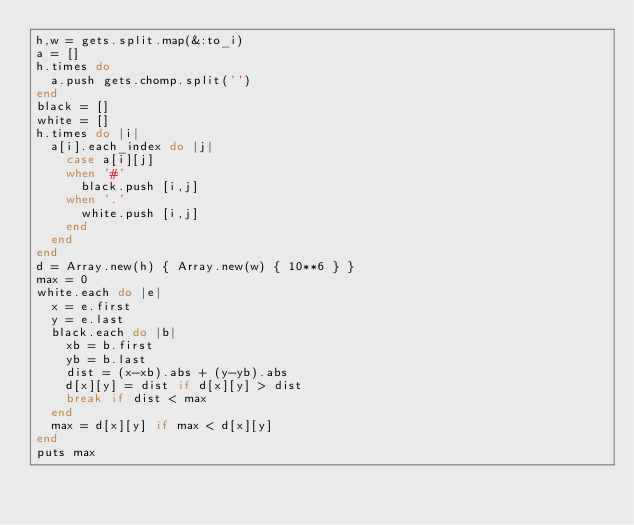Convert code to text. <code><loc_0><loc_0><loc_500><loc_500><_Ruby_>h,w = gets.split.map(&:to_i)
a = []
h.times do
  a.push gets.chomp.split('')
end
black = []
white = []
h.times do |i|
  a[i].each_index do |j|
    case a[i][j]
    when '#'
      black.push [i,j]
    when '.'
      white.push [i,j]
    end
  end
end
d = Array.new(h) { Array.new(w) { 10**6 } }
max = 0
white.each do |e|
  x = e.first
  y = e.last
  black.each do |b|
    xb = b.first
    yb = b.last
    dist = (x-xb).abs + (y-yb).abs
    d[x][y] = dist if d[x][y] > dist
    break if dist < max
  end
  max = d[x][y] if max < d[x][y]
end
puts max
</code> 